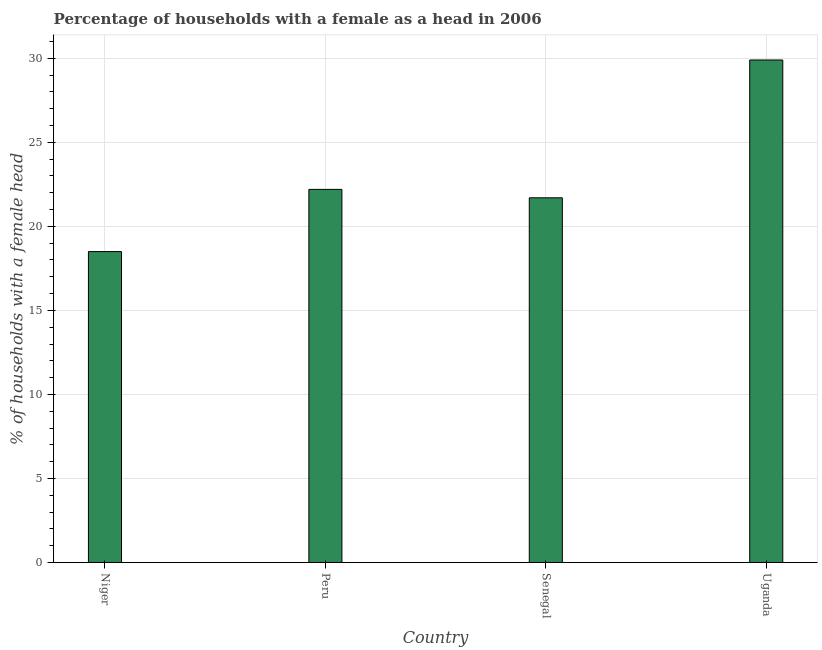Does the graph contain any zero values?
Your answer should be very brief. No. What is the title of the graph?
Offer a terse response. Percentage of households with a female as a head in 2006. What is the label or title of the Y-axis?
Provide a short and direct response. % of households with a female head. What is the number of female supervised households in Uganda?
Your answer should be compact. 29.9. Across all countries, what is the maximum number of female supervised households?
Give a very brief answer. 29.9. In which country was the number of female supervised households maximum?
Your answer should be compact. Uganda. In which country was the number of female supervised households minimum?
Your response must be concise. Niger. What is the sum of the number of female supervised households?
Offer a very short reply. 92.3. What is the difference between the number of female supervised households in Peru and Uganda?
Ensure brevity in your answer.  -7.7. What is the average number of female supervised households per country?
Your answer should be compact. 23.07. What is the median number of female supervised households?
Give a very brief answer. 21.95. What is the ratio of the number of female supervised households in Peru to that in Uganda?
Make the answer very short. 0.74. Is the sum of the number of female supervised households in Niger and Senegal greater than the maximum number of female supervised households across all countries?
Keep it short and to the point. Yes. What is the difference between the highest and the lowest number of female supervised households?
Provide a short and direct response. 11.4. How many countries are there in the graph?
Your response must be concise. 4. Are the values on the major ticks of Y-axis written in scientific E-notation?
Keep it short and to the point. No. What is the % of households with a female head in Peru?
Your answer should be very brief. 22.2. What is the % of households with a female head of Senegal?
Keep it short and to the point. 21.7. What is the % of households with a female head in Uganda?
Offer a terse response. 29.9. What is the difference between the % of households with a female head in Niger and Peru?
Keep it short and to the point. -3.7. What is the difference between the % of households with a female head in Niger and Senegal?
Your answer should be very brief. -3.2. What is the difference between the % of households with a female head in Peru and Senegal?
Give a very brief answer. 0.5. What is the ratio of the % of households with a female head in Niger to that in Peru?
Keep it short and to the point. 0.83. What is the ratio of the % of households with a female head in Niger to that in Senegal?
Ensure brevity in your answer.  0.85. What is the ratio of the % of households with a female head in Niger to that in Uganda?
Offer a very short reply. 0.62. What is the ratio of the % of households with a female head in Peru to that in Uganda?
Offer a terse response. 0.74. What is the ratio of the % of households with a female head in Senegal to that in Uganda?
Make the answer very short. 0.73. 